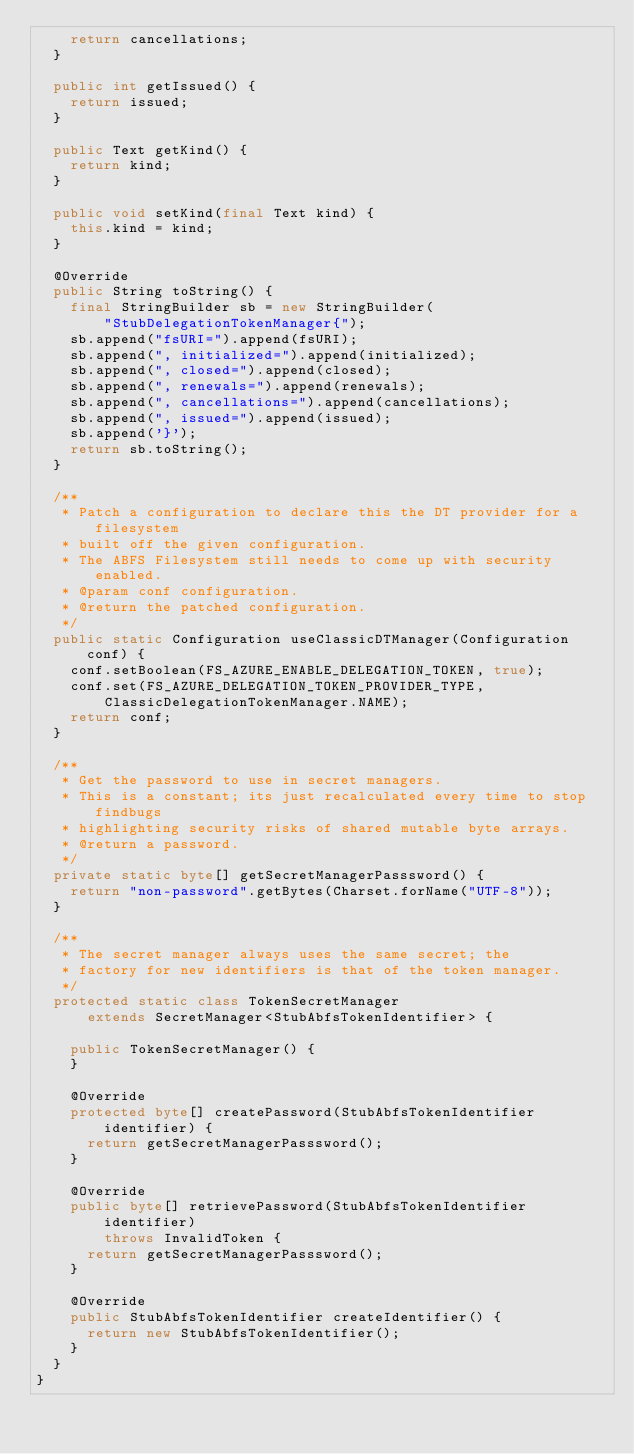<code> <loc_0><loc_0><loc_500><loc_500><_Java_>    return cancellations;
  }

  public int getIssued() {
    return issued;
  }

  public Text getKind() {
    return kind;
  }

  public void setKind(final Text kind) {
    this.kind = kind;
  }

  @Override
  public String toString() {
    final StringBuilder sb = new StringBuilder(
        "StubDelegationTokenManager{");
    sb.append("fsURI=").append(fsURI);
    sb.append(", initialized=").append(initialized);
    sb.append(", closed=").append(closed);
    sb.append(", renewals=").append(renewals);
    sb.append(", cancellations=").append(cancellations);
    sb.append(", issued=").append(issued);
    sb.append('}');
    return sb.toString();
  }

  /**
   * Patch a configuration to declare this the DT provider for a filesystem
   * built off the given configuration.
   * The ABFS Filesystem still needs to come up with security enabled.
   * @param conf configuration.
   * @return the patched configuration.
   */
  public static Configuration useClassicDTManager(Configuration conf) {
    conf.setBoolean(FS_AZURE_ENABLE_DELEGATION_TOKEN, true);
    conf.set(FS_AZURE_DELEGATION_TOKEN_PROVIDER_TYPE,
        ClassicDelegationTokenManager.NAME);
    return conf;
  }

  /**
   * Get the password to use in secret managers.
   * This is a constant; its just recalculated every time to stop findbugs
   * highlighting security risks of shared mutable byte arrays.
   * @return a password.
   */
  private static byte[] getSecretManagerPasssword() {
    return "non-password".getBytes(Charset.forName("UTF-8"));
  }

  /**
   * The secret manager always uses the same secret; the
   * factory for new identifiers is that of the token manager.
   */
  protected static class TokenSecretManager
      extends SecretManager<StubAbfsTokenIdentifier> {

    public TokenSecretManager() {
    }

    @Override
    protected byte[] createPassword(StubAbfsTokenIdentifier identifier) {
      return getSecretManagerPasssword();
    }

    @Override
    public byte[] retrievePassword(StubAbfsTokenIdentifier identifier)
        throws InvalidToken {
      return getSecretManagerPasssword();
    }

    @Override
    public StubAbfsTokenIdentifier createIdentifier() {
      return new StubAbfsTokenIdentifier();
    }
  }
}
</code> 